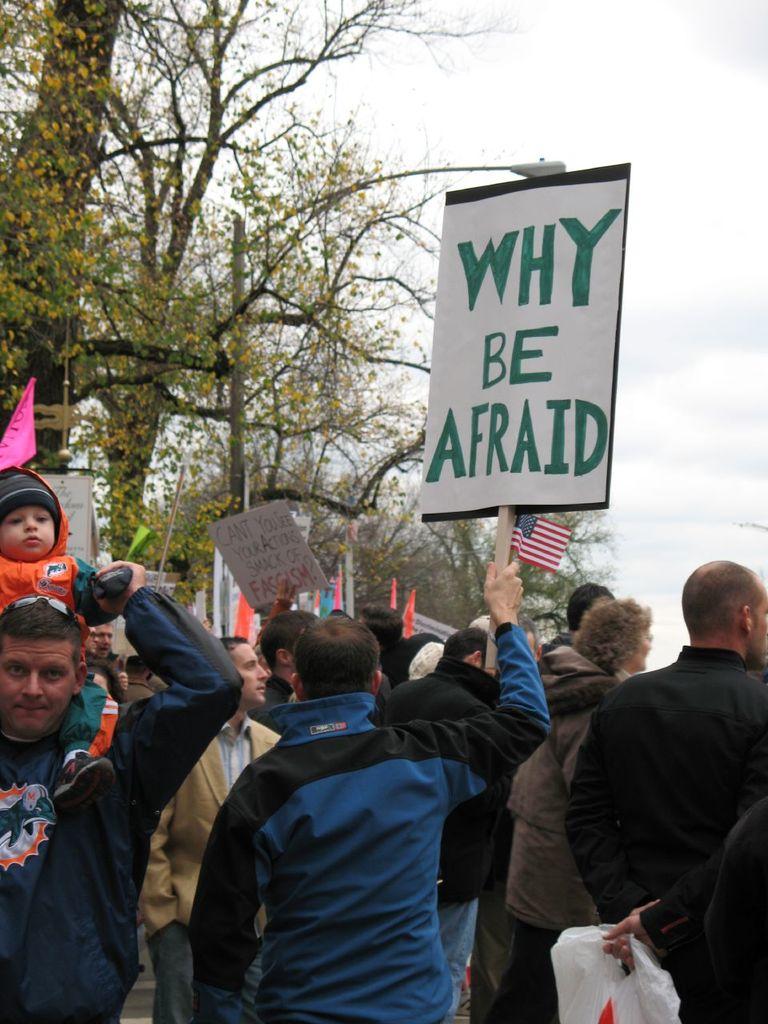According to the sign with red text in the background, what do your actions smack of?
Offer a terse response. Fascism. What does the green sign say?
Give a very brief answer. Why be afraid. 